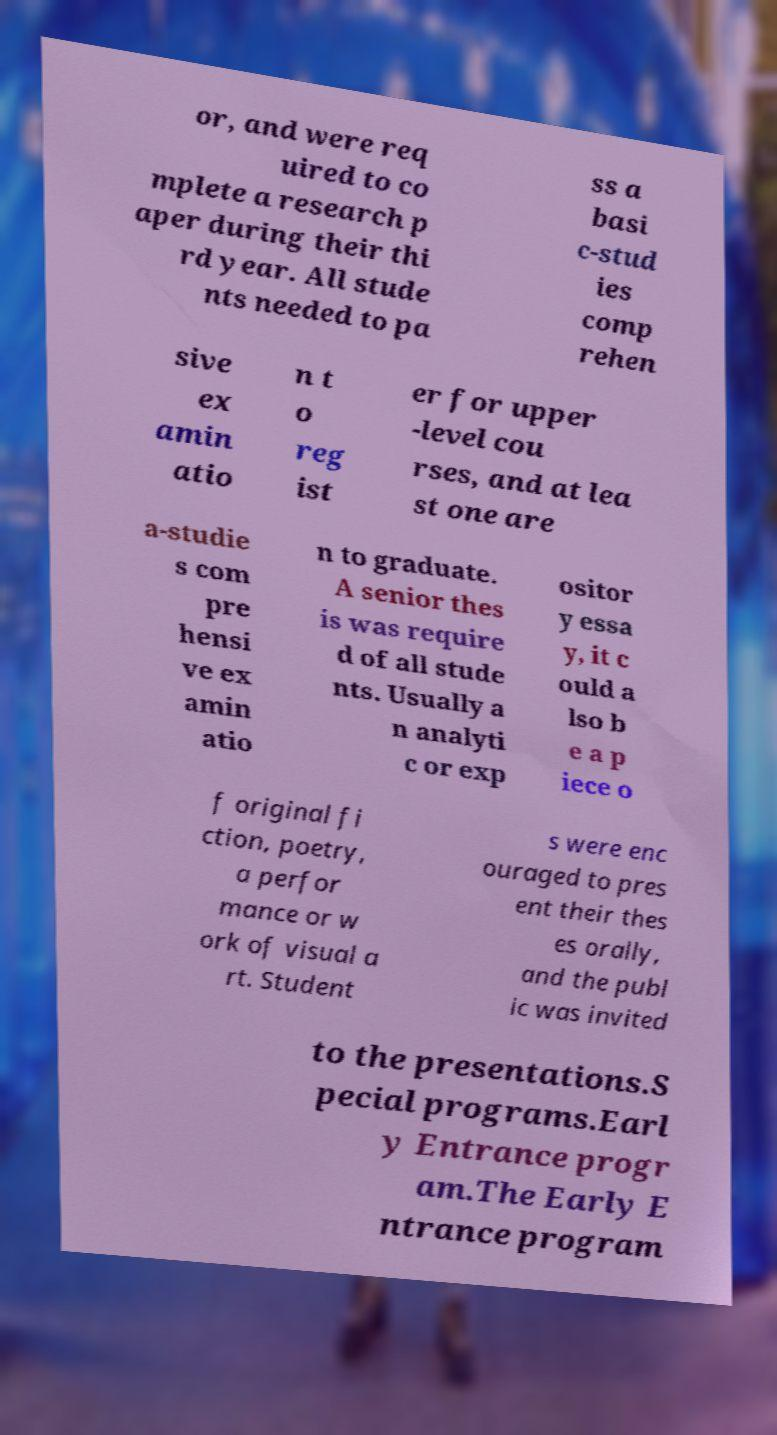I need the written content from this picture converted into text. Can you do that? or, and were req uired to co mplete a research p aper during their thi rd year. All stude nts needed to pa ss a basi c-stud ies comp rehen sive ex amin atio n t o reg ist er for upper -level cou rses, and at lea st one are a-studie s com pre hensi ve ex amin atio n to graduate. A senior thes is was require d of all stude nts. Usually a n analyti c or exp ositor y essa y, it c ould a lso b e a p iece o f original fi ction, poetry, a perfor mance or w ork of visual a rt. Student s were enc ouraged to pres ent their thes es orally, and the publ ic was invited to the presentations.S pecial programs.Earl y Entrance progr am.The Early E ntrance program 